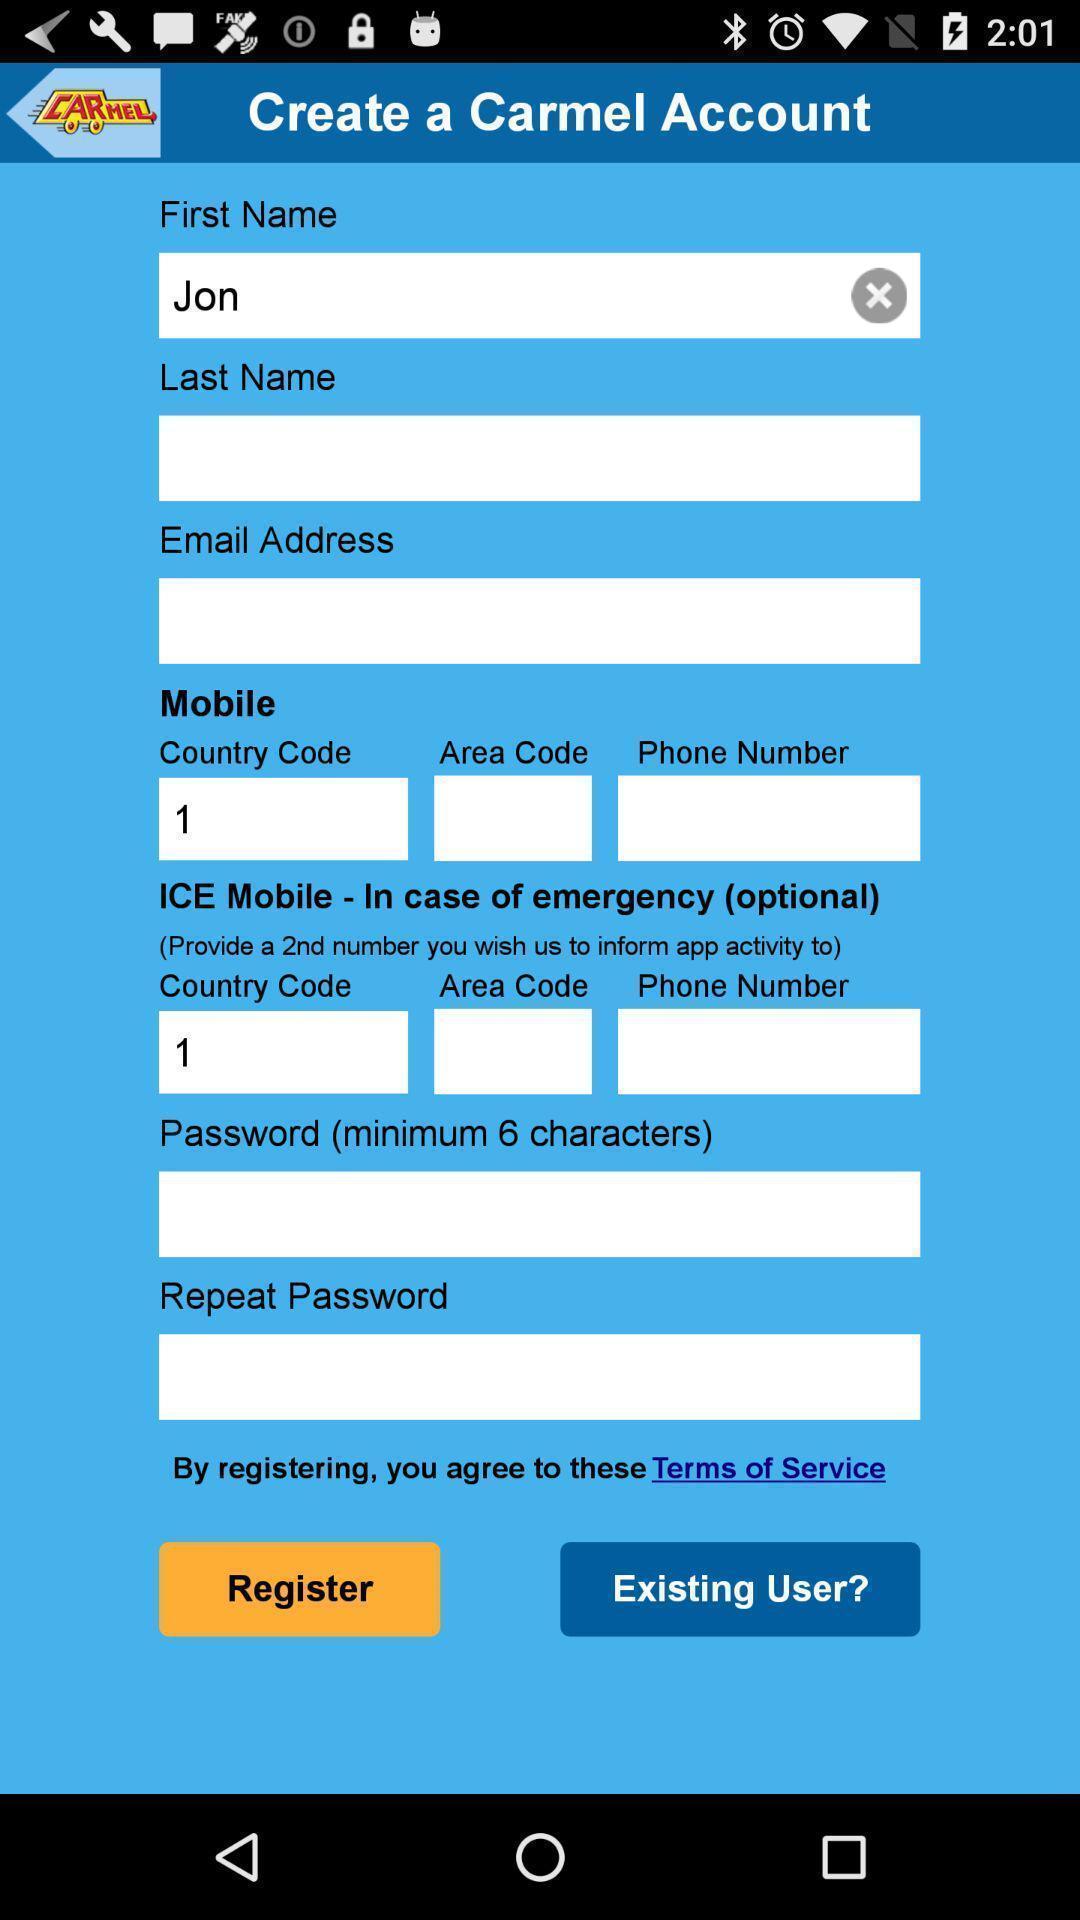Tell me what you see in this picture. Page showing login credentials on app. 